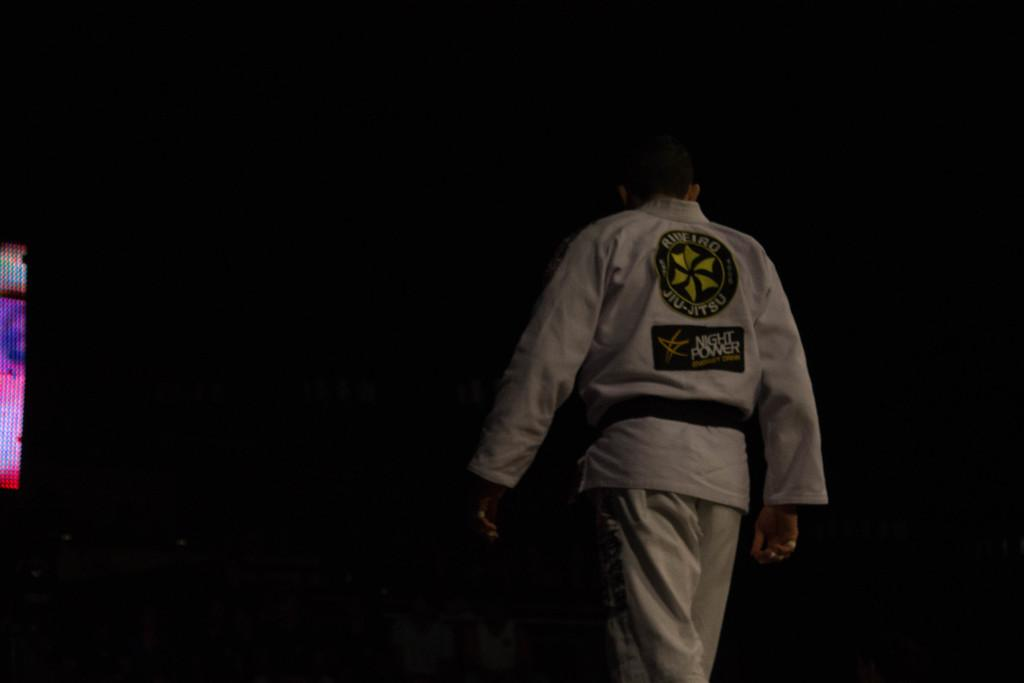<image>
Offer a succinct explanation of the picture presented. A martial arts practitioner has a sticker labeled NIGHT POWER attached to the back of his robe. 